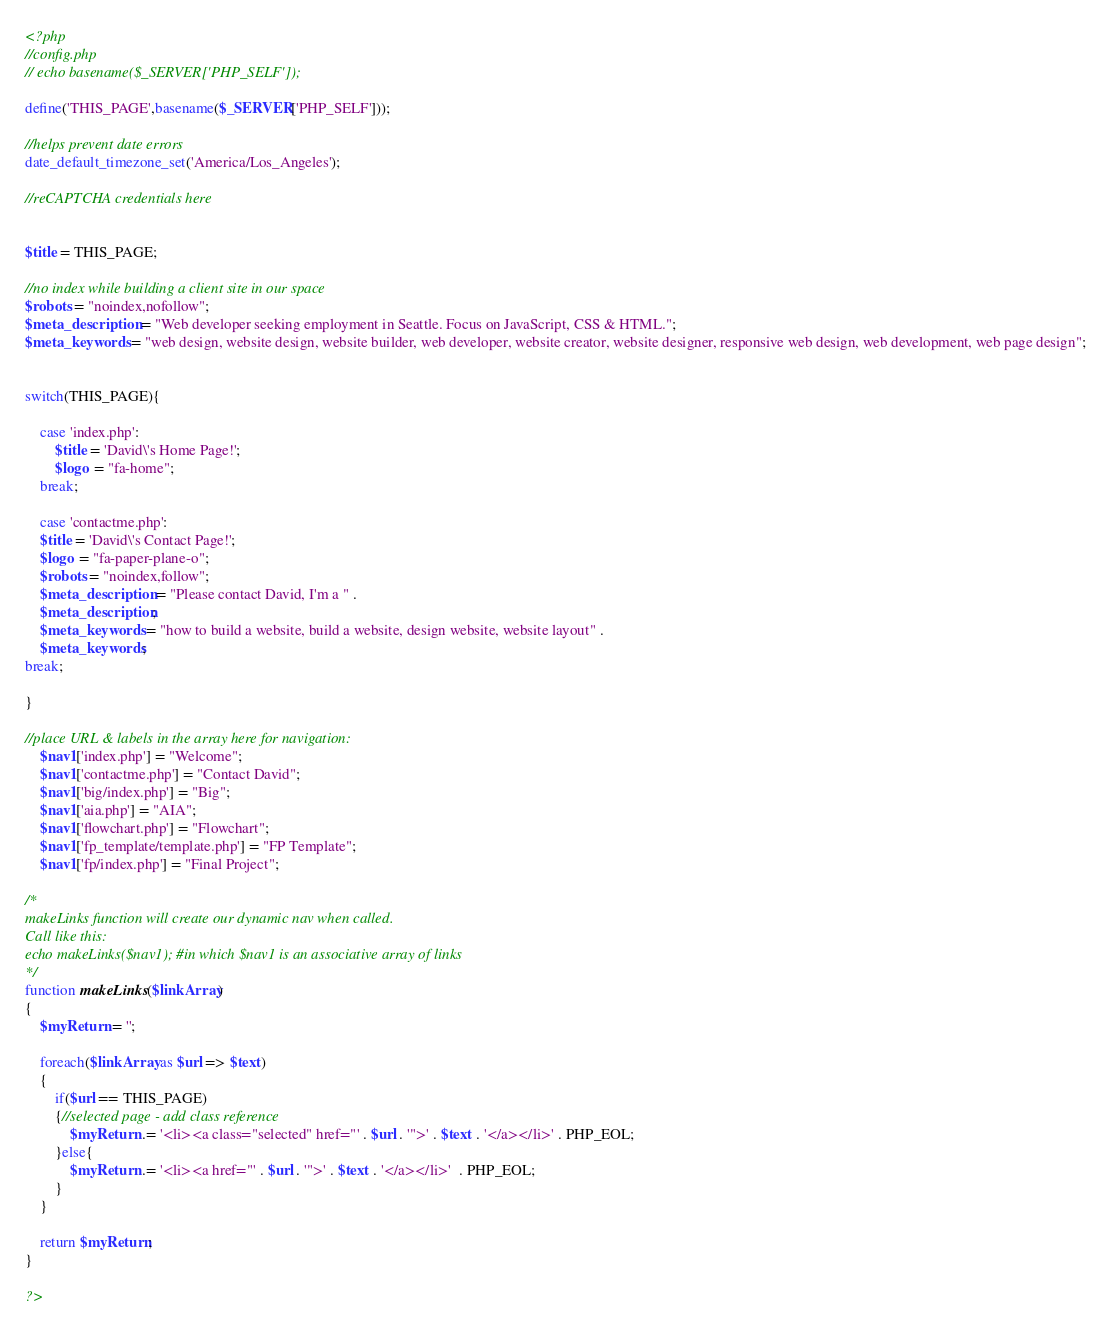Convert code to text. <code><loc_0><loc_0><loc_500><loc_500><_PHP_><?php
//config.php
// echo basename($_SERVER['PHP_SELF']);

define('THIS_PAGE',basename($_SERVER['PHP_SELF']));

//helps prevent date errors
date_default_timezone_set('America/Los_Angeles');

//reCAPTCHA credentials here


$title = THIS_PAGE;

//no index while building a client site in our space
$robots = "noindex,nofollow";
$meta_description = "Web developer seeking employment in Seattle. Focus on JavaScript, CSS & HTML.";
$meta_keywords = "web design, website design, website builder, web developer, website creator, website designer, responsive web design, web development, web page design";


switch(THIS_PAGE){

    case 'index.php':
        $title = 'David\'s Home Page!';
        $logo = "fa-home";
    break;

    case 'contactme.php':
    $title = 'David\'s Contact Page!';
    $logo = "fa-paper-plane-o";
    $robots = "noindex,follow";
    $meta_description = "Please contact David, I'm a " . 
    $meta_description;
    $meta_keywords = "how to build a website, build a website, design website, website layout" .
    $meta_keywords;
break;

}

//place URL & labels in the array here for navigation:
    $nav1['index.php'] = "Welcome";
    $nav1['contactme.php'] = "Contact David";
    $nav1['big/index.php'] = "Big";
    $nav1['aia.php'] = "AIA";
    $nav1['flowchart.php'] = "Flowchart";
    $nav1['fp_template/template.php'] = "FP Template";
    $nav1['fp/index.php'] = "Final Project";
       
/*
makeLinks function will create our dynamic nav when called.
Call like this:
echo makeLinks($nav1); #in which $nav1 is an associative array of links
*/
function makeLinks($linkArray)
{
    $myReturn = '';

    foreach($linkArray as $url => $text)
    {
        if($url == THIS_PAGE)
        {//selected page - add class reference
	    	$myReturn .= '<li><a class="selected" href="' . $url . '">' . $text . '</a></li>' . PHP_EOL;
    	}else{
	    	$myReturn .= '<li><a href="' . $url . '">' . $text . '</a></li>'  . PHP_EOL;
    	}    
    }
      
    return $myReturn;    
}

?></code> 